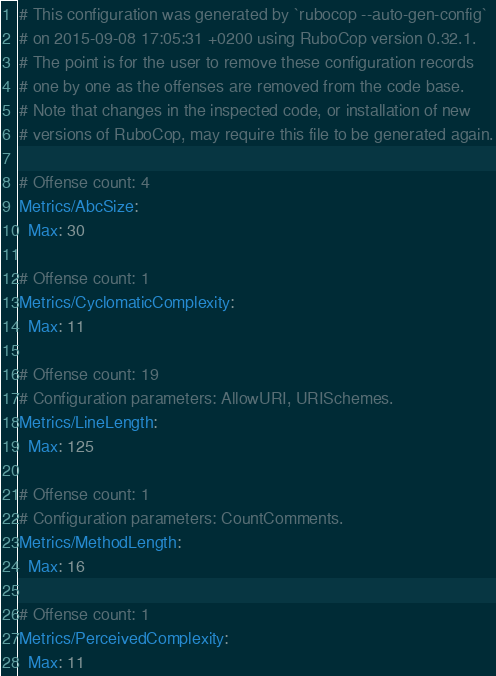<code> <loc_0><loc_0><loc_500><loc_500><_YAML_># This configuration was generated by `rubocop --auto-gen-config`
# on 2015-09-08 17:05:31 +0200 using RuboCop version 0.32.1.
# The point is for the user to remove these configuration records
# one by one as the offenses are removed from the code base.
# Note that changes in the inspected code, or installation of new
# versions of RuboCop, may require this file to be generated again.

# Offense count: 4
Metrics/AbcSize:
  Max: 30

# Offense count: 1
Metrics/CyclomaticComplexity:
  Max: 11

# Offense count: 19
# Configuration parameters: AllowURI, URISchemes.
Metrics/LineLength:
  Max: 125

# Offense count: 1
# Configuration parameters: CountComments.
Metrics/MethodLength:
  Max: 16

# Offense count: 1
Metrics/PerceivedComplexity:
  Max: 11
</code> 